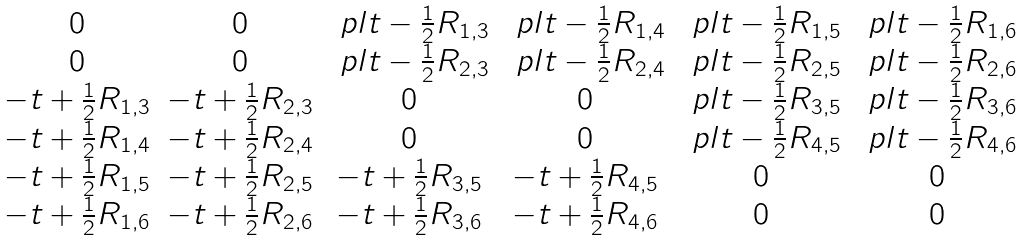<formula> <loc_0><loc_0><loc_500><loc_500>\begin{matrix} 0 & 0 & \ p l t - \frac { 1 } { 2 } R _ { 1 , 3 } & \ p l t - \frac { 1 } { 2 } R _ { 1 , 4 } & \ p l t - \frac { 1 } { 2 } R _ { 1 , 5 } & \ p l t - \frac { 1 } { 2 } R _ { 1 , 6 } \\ 0 & 0 & \ p l t - \frac { 1 } { 2 } R _ { 2 , 3 } & \ p l t - \frac { 1 } { 2 } R _ { 2 , 4 } & \ p l t - \frac { 1 } { 2 } R _ { 2 , 5 } & \ p l t - \frac { 1 } { 2 } R _ { 2 , 6 } \\ - t + \frac { 1 } { 2 } R _ { 1 , 3 } & - t + \frac { 1 } { 2 } R _ { 2 , 3 } & 0 & 0 & \ p l t - \frac { 1 } { 2 } R _ { 3 , 5 } & \ p l t - \frac { 1 } { 2 } R _ { 3 , 6 } \\ - t + \frac { 1 } { 2 } R _ { 1 , 4 } & - t + \frac { 1 } { 2 } R _ { 2 , 4 } & 0 & 0 & \ p l t - \frac { 1 } { 2 } R _ { 4 , 5 } & \ p l t - \frac { 1 } { 2 } R _ { 4 , 6 } \\ - t + \frac { 1 } { 2 } R _ { 1 , 5 } & - t + \frac { 1 } { 2 } R _ { 2 , 5 } & - t + \frac { 1 } { 2 } R _ { 3 , 5 } & - t + \frac { 1 } { 2 } R _ { 4 , 5 } & 0 & 0 \\ - t + \frac { 1 } { 2 } R _ { 1 , 6 } & - t + \frac { 1 } { 2 } R _ { 2 , 6 } & - t + \frac { 1 } { 2 } R _ { 3 , 6 } & - t + \frac { 1 } { 2 } R _ { 4 , 6 } & 0 & 0 \end{matrix}</formula> 